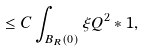Convert formula to latex. <formula><loc_0><loc_0><loc_500><loc_500>\leq C \int _ { B _ { R } ( 0 ) } \xi Q ^ { 2 } \ast 1 ,</formula> 